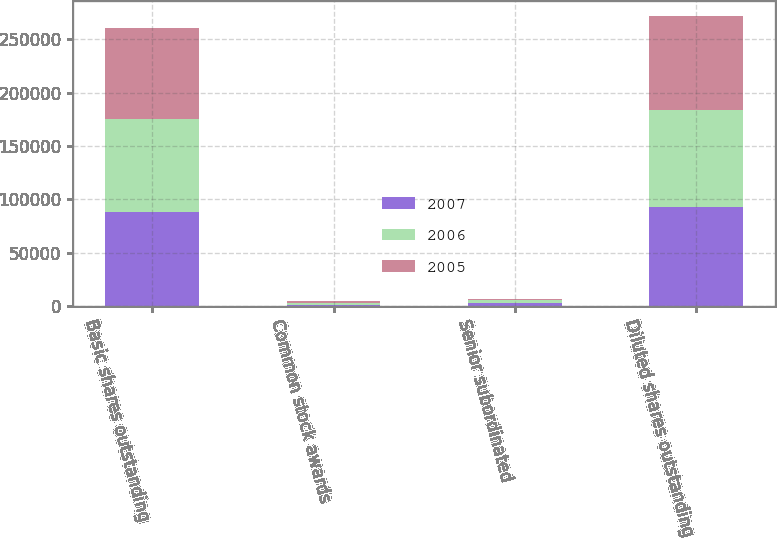Convert chart. <chart><loc_0><loc_0><loc_500><loc_500><stacked_bar_chart><ecel><fcel>Basic shares outstanding<fcel>Common stock awards<fcel>Senior subordinated<fcel>Diluted shares outstanding<nl><fcel>2007<fcel>88390<fcel>1511<fcel>3328<fcel>93229<nl><fcel>2006<fcel>86842<fcel>1823<fcel>2215<fcel>90880<nl><fcel>2005<fcel>85498<fcel>1631<fcel>755<fcel>87884<nl></chart> 